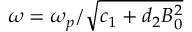<formula> <loc_0><loc_0><loc_500><loc_500>\omega = \omega _ { p } / \sqrt { c _ { 1 } + d _ { 2 } B _ { 0 } ^ { 2 } }</formula> 